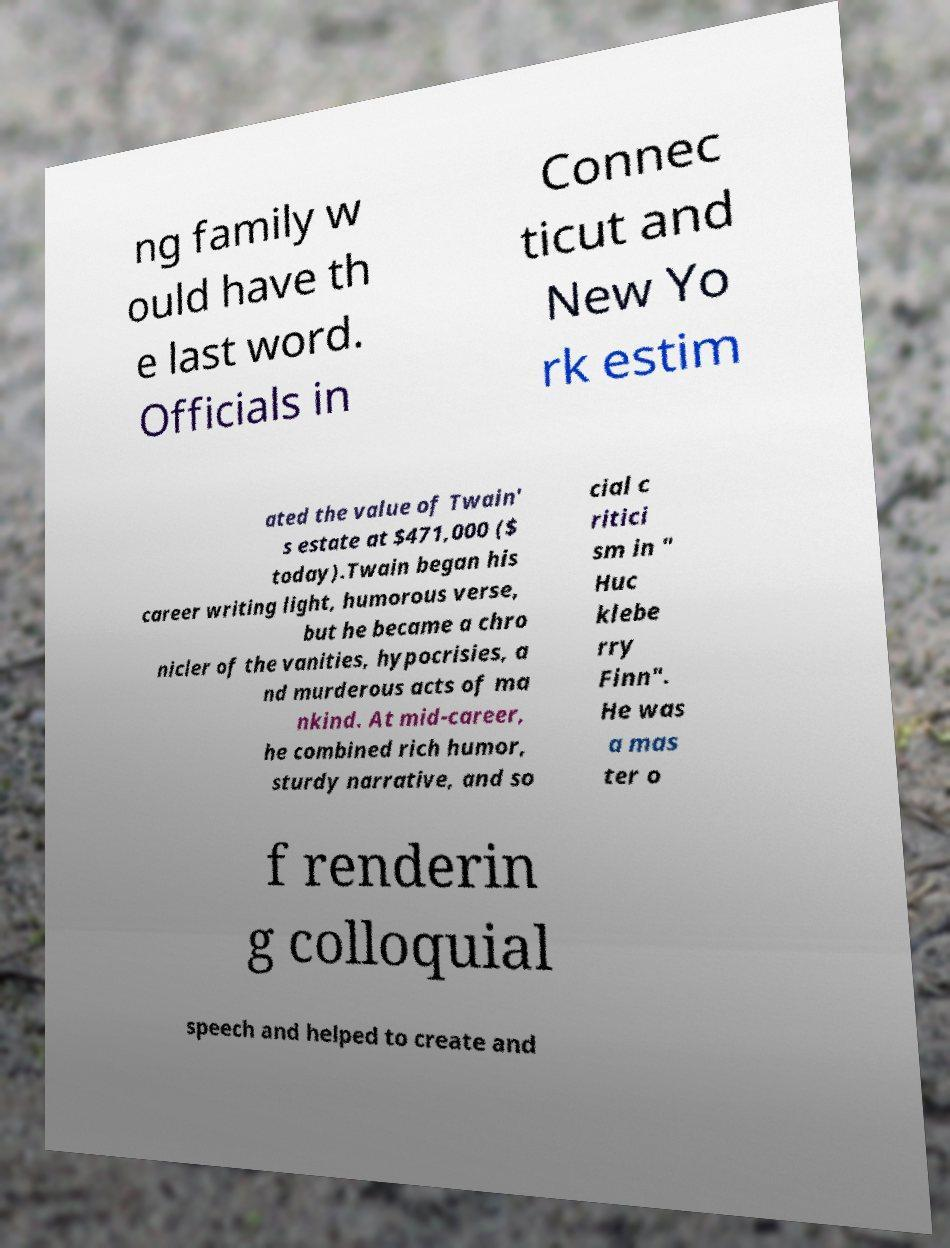Could you extract and type out the text from this image? ng family w ould have th e last word. Officials in Connec ticut and New Yo rk estim ated the value of Twain' s estate at $471,000 ($ today).Twain began his career writing light, humorous verse, but he became a chro nicler of the vanities, hypocrisies, a nd murderous acts of ma nkind. At mid-career, he combined rich humor, sturdy narrative, and so cial c ritici sm in " Huc klebe rry Finn". He was a mas ter o f renderin g colloquial speech and helped to create and 